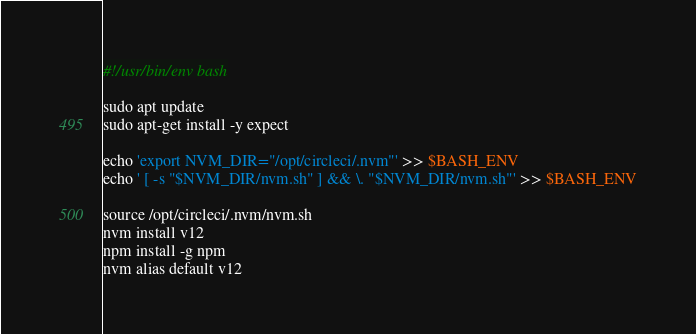<code> <loc_0><loc_0><loc_500><loc_500><_Bash_>#!/usr/bin/env bash

sudo apt update
sudo apt-get install -y expect

echo 'export NVM_DIR="/opt/circleci/.nvm"' >> $BASH_ENV
echo ' [ -s "$NVM_DIR/nvm.sh" ] && \. "$NVM_DIR/nvm.sh"' >> $BASH_ENV

source /opt/circleci/.nvm/nvm.sh
nvm install v12
npm install -g npm
nvm alias default v12
</code> 